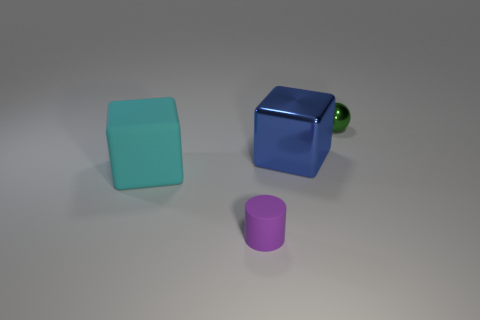The metal sphere that is the same size as the purple thing is what color?
Provide a succinct answer. Green. What number of other large things are the same shape as the green object?
Give a very brief answer. 0. What number of cylinders are big blue metallic objects or large cyan rubber things?
Your answer should be very brief. 0. Is the shape of the small object that is behind the cyan cube the same as the big object behind the big rubber cube?
Your response must be concise. No. What material is the tiny sphere?
Make the answer very short. Metal. What number of blue blocks have the same size as the green object?
Keep it short and to the point. 0. What number of things are either cubes that are behind the large cyan rubber cube or big things that are on the right side of the large cyan thing?
Give a very brief answer. 1. Does the cube in front of the blue block have the same material as the tiny thing in front of the small green metallic object?
Make the answer very short. Yes. What shape is the tiny purple matte object that is in front of the shiny thing to the left of the tiny green metal sphere?
Ensure brevity in your answer.  Cylinder. Is there any other thing of the same color as the large rubber cube?
Offer a very short reply. No. 